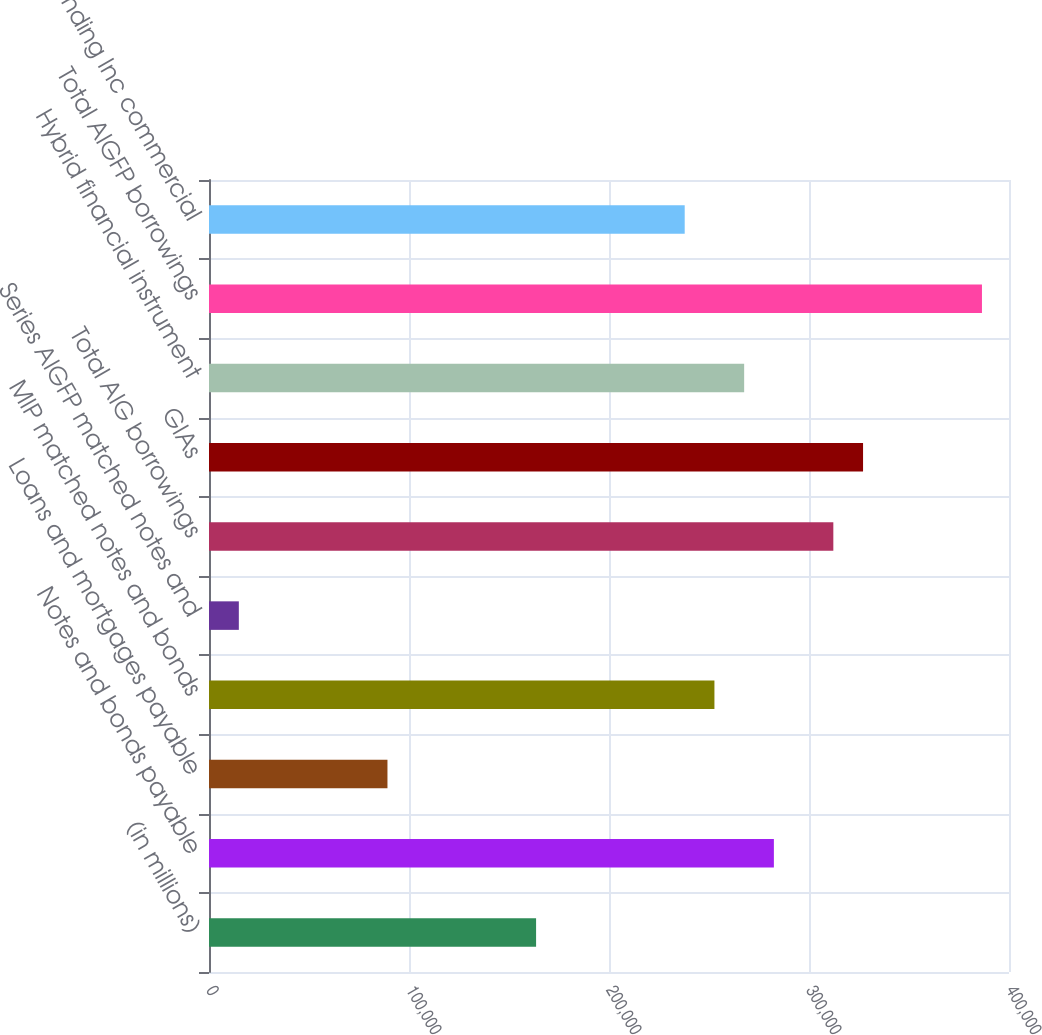Convert chart. <chart><loc_0><loc_0><loc_500><loc_500><bar_chart><fcel>(in millions)<fcel>Notes and bonds payable<fcel>Loans and mortgages payable<fcel>MIP matched notes and bonds<fcel>Series AIGFP matched notes and<fcel>Total AIG borrowings<fcel>GIAs<fcel>Hybrid financial instrument<fcel>Total AIGFP borrowings<fcel>AIG Funding Inc commercial<nl><fcel>163541<fcel>282441<fcel>89229.4<fcel>252716<fcel>14917.4<fcel>312165<fcel>327028<fcel>267578<fcel>386477<fcel>237853<nl></chart> 